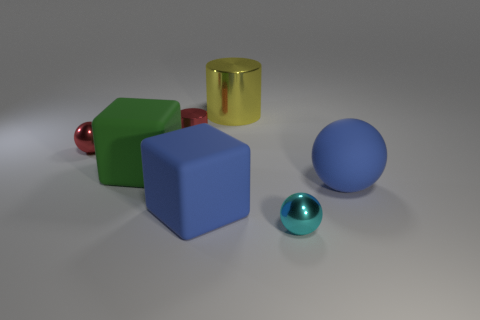Add 1 big blue things. How many objects exist? 8 Subtract all large rubber balls. How many balls are left? 2 Subtract all green blocks. How many blocks are left? 1 Subtract all blocks. How many objects are left? 5 Subtract all red balls. Subtract all brown cubes. How many balls are left? 2 Subtract all cyan balls. How many red cylinders are left? 1 Subtract all large objects. Subtract all small red metal cylinders. How many objects are left? 2 Add 2 blue rubber cubes. How many blue rubber cubes are left? 3 Add 2 large blue rubber cubes. How many large blue rubber cubes exist? 3 Subtract 0 red cubes. How many objects are left? 7 